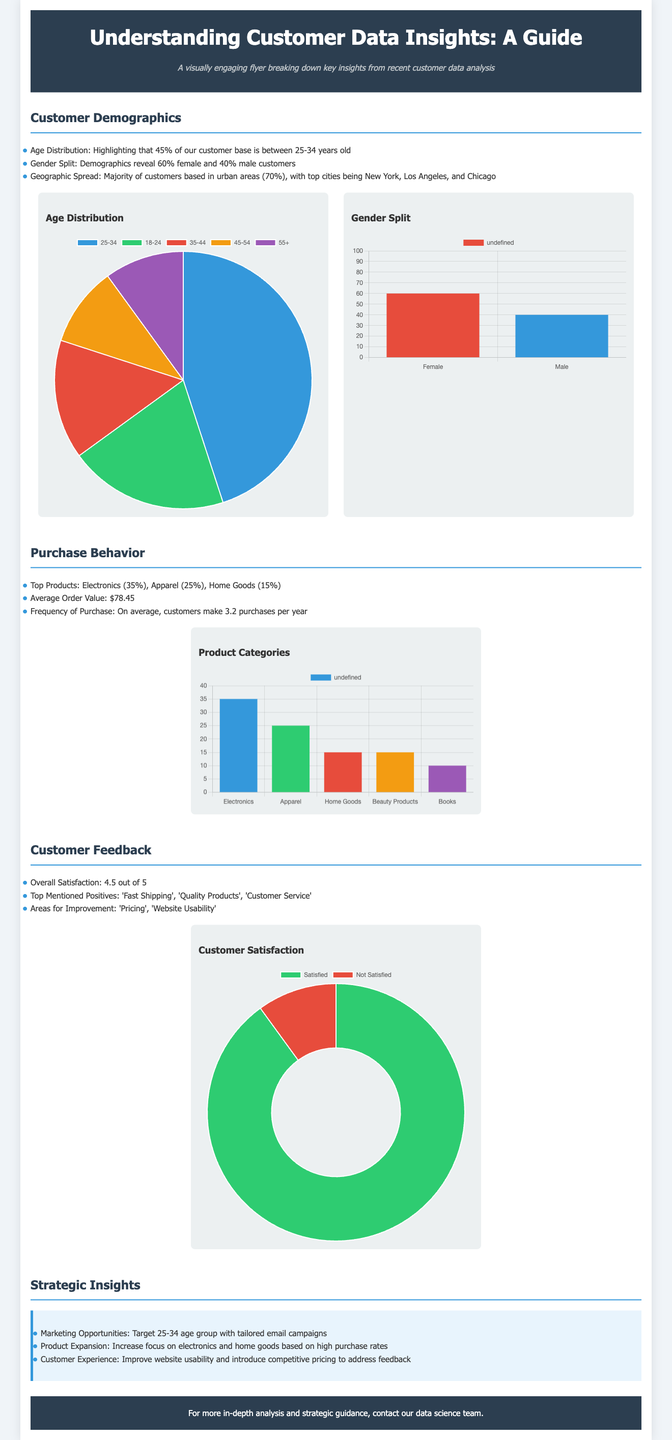What percentage of the customer base is between 25-34 years old? The document states that 45% of the customer base falls within the age range of 25-34 years.
Answer: 45% What is the gender split in the customer demographics? According to the flyer, the gender split shows 60% female and 40% male customers.
Answer: 60% female and 40% male What is the average order value? The average order value mentioned in the document is $78.45.
Answer: $78.45 How many purchases do customers make on average per year? The document notes that customers make an average of 3.2 purchases each year.
Answer: 3.2 What is the overall customer satisfaction rating? The overall satisfaction rating provided in the flyer is 4.5 out of 5.
Answer: 4.5 out of 5 Which product category has the highest purchase rate? The top product category identified in the document is Electronics, with a purchase rate of 35%.
Answer: Electronics What is one area for improvement mentioned in the customer feedback? The document highlights 'Pricing' as a key area for improvement based on customer feedback.
Answer: Pricing What marketing opportunity is suggested in the strategic insights? The flyer suggests targeting the 25-34 age group with tailored email campaigns as a marketing opportunity.
Answer: Target 25-34 age group with tailored email campaigns How many top cities are mentioned for the geographic spread of customers? The document lists three top cities where the majority of customers are based.
Answer: Three 